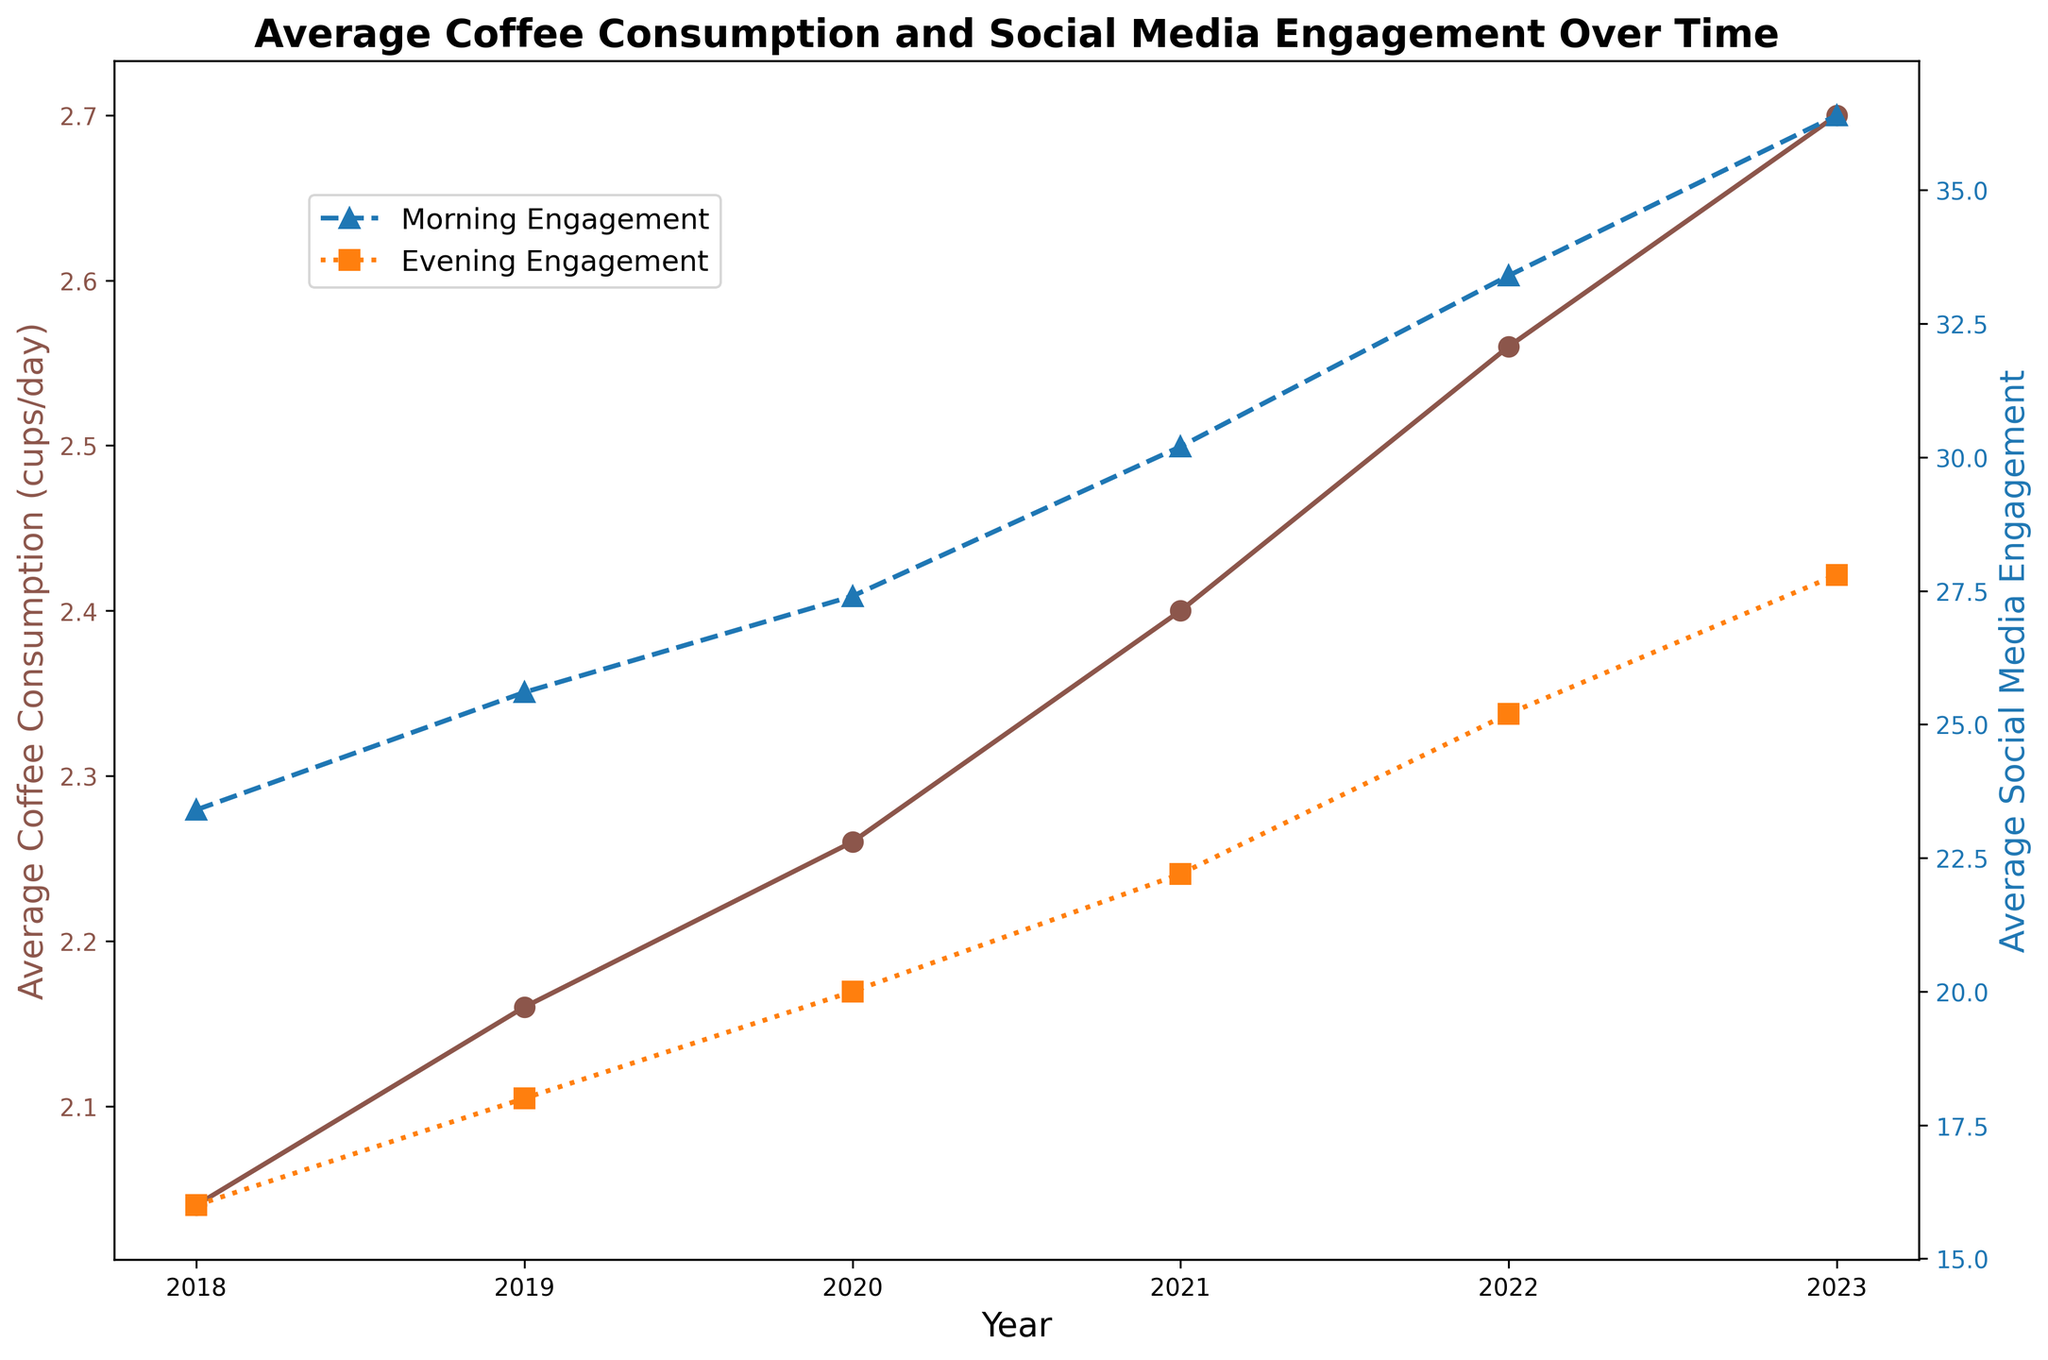What is the trend in average coffee consumption from 2018 to 2023? To determine the trend, observe the brown line representing 'Average Coffee Consumption' on the primary y-axis from 2018 to 2023. Each year, coffee consumption increases slightly, indicating a steady upward trend over time.
Answer: Increasing trend How does morning social media engagement in 2023 compare to that in 2018? Look at the blue line representing 'Morning Social Engagement' on the secondary y-axis. In 2018, it was 30 units, and in 2023, it increased to 48 units, showing a significant rise in morning social engagement.
Answer: Higher in 2023 What was the change in evening social media engagement between 2020 and 2021? Observe the orange line for 'Evening Social Engagement' on the secondary y-axis. In 2020, evening engagement was 20 units, and in 2021, it increased to 30 units. Calculate the change by subtracting 20 from 30.
Answer: Increased by 10 units Which year had the highest average coffee consumption? To find the year with the highest coffee consumption, follow the brown line on the primary axis to see the peak point. The brown line peaks at 2023 with an average consumption of 2.72 cups/day.
Answer: 2023 Was there a year when morning social media engagement was equal to evening social media engagement? Track both the blue (morning) and orange (evening) lines on the secondary y-axis across years. Both lines intersect at 2018 where morning engagement (30 units) is equal to evening engagement (30 units).
Answer: 2018 Between which years is the increase in coffee consumption most significant? Look at the brown line on the primary y-axis and analyze the slope differences between each consecutive year. The steepest increase happens between 2022 and 2023, where the consumption rises from 2.8 to 2.9 cups/day.
Answer: Between 2022 and 2023 In what year did the 35-44 age group have the highest coffee consumption? Notice the individual age group trends linked to each year on the brown line. The highest consumption for the 35-44 group is 2023 with an average of 3.2 cups/day.
Answer: 2023 What is the average morning social media engagement over the entire period (2018-2023)? Sum the average morning social media engagement values for each year (30+33+35+40+45+48) and divide by the total number of years (6).
Answer: 38.5 units Compare the levels of evening social media engagement in 2021 and 2022. Which year saw a higher engagement and by how much? Check the orange line on the secondary y-axis for evening engagement in 2021 (30 units) and 2022 (33 units). Subtract 30 from 33 to get the difference.
Answer: 2022 had 3 units higher What is the visual difference between the peak points of coffee consumption and morning social media engagement in 2023? The brown line peaks at approximately 3.2 cups/day for coffee consumption, while the blue line for morning social media engagement hits 60 units. Visually, the brown peak is lower and to the left relative to the blue peak.
Answer: Coffee: ~3.2 cups/day, Morning Social Media: 60 units 